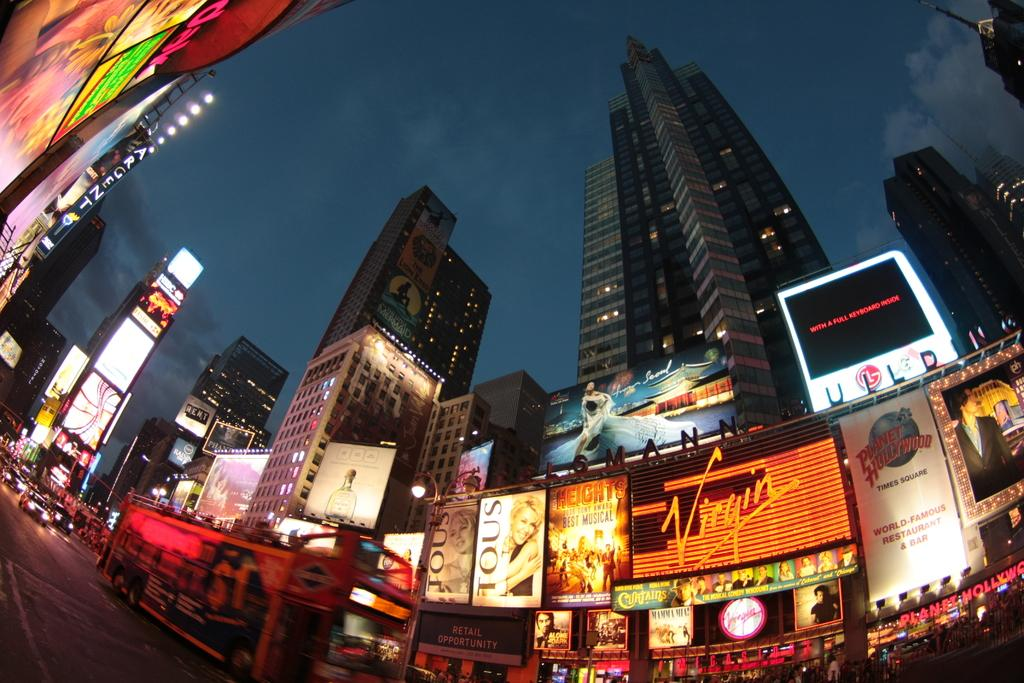What can be seen on the road in the image? There are vehicles on the road in the image. What else is visible besides the vehicles on the road? Boards, lights, poles, buildings, and the sky are visible in the image. Can you describe the lights in the image? The lights are likely streetlights or traffic lights. What is the background of the image? The sky is visible in the background of the image. Can you see a goose holding a pen in the image? No, there is no goose or pen present in the image. 